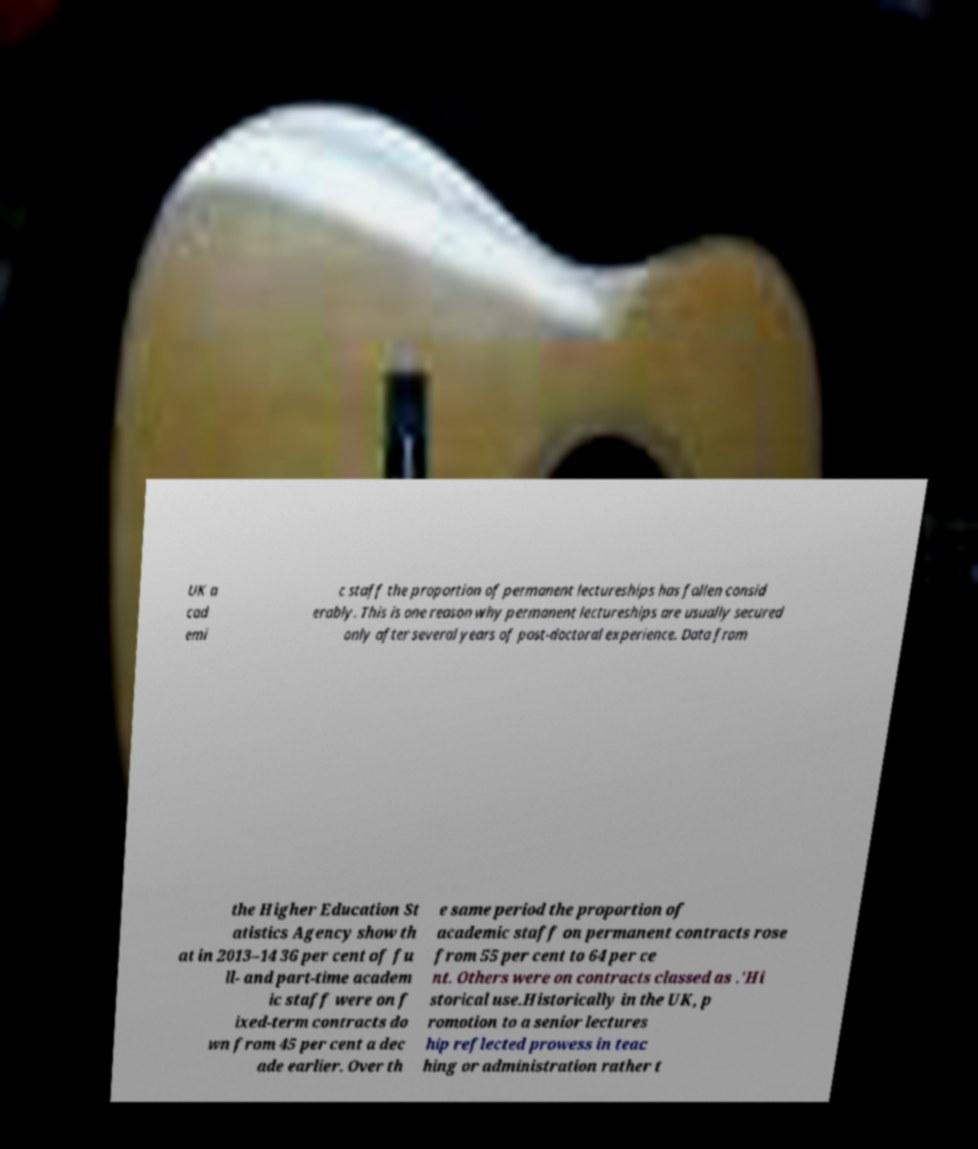Could you assist in decoding the text presented in this image and type it out clearly? UK a cad emi c staff the proportion of permanent lectureships has fallen consid erably. This is one reason why permanent lectureships are usually secured only after several years of post-doctoral experience. Data from the Higher Education St atistics Agency show th at in 2013–14 36 per cent of fu ll- and part-time academ ic staff were on f ixed-term contracts do wn from 45 per cent a dec ade earlier. Over th e same period the proportion of academic staff on permanent contracts rose from 55 per cent to 64 per ce nt. Others were on contracts classed as .'Hi storical use.Historically in the UK, p romotion to a senior lectures hip reflected prowess in teac hing or administration rather t 